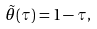<formula> <loc_0><loc_0><loc_500><loc_500>\tilde { \theta } ( \tau ) = 1 - \tau ,</formula> 